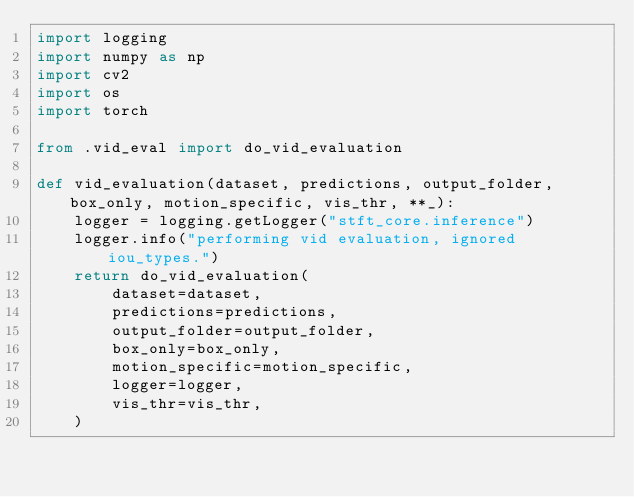<code> <loc_0><loc_0><loc_500><loc_500><_Python_>import logging
import numpy as np
import cv2
import os
import torch

from .vid_eval import do_vid_evaluation

def vid_evaluation(dataset, predictions, output_folder, box_only, motion_specific, vis_thr, **_):
    logger = logging.getLogger("stft_core.inference")
    logger.info("performing vid evaluation, ignored iou_types.")
    return do_vid_evaluation(
        dataset=dataset,
        predictions=predictions,
        output_folder=output_folder,
        box_only=box_only,
        motion_specific=motion_specific,
        logger=logger,
        vis_thr=vis_thr,
    )
</code> 